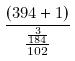<formula> <loc_0><loc_0><loc_500><loc_500>\frac { ( 3 9 4 + 1 ) } { \frac { \frac { 3 } { 1 8 4 } } { 1 0 2 } }</formula> 